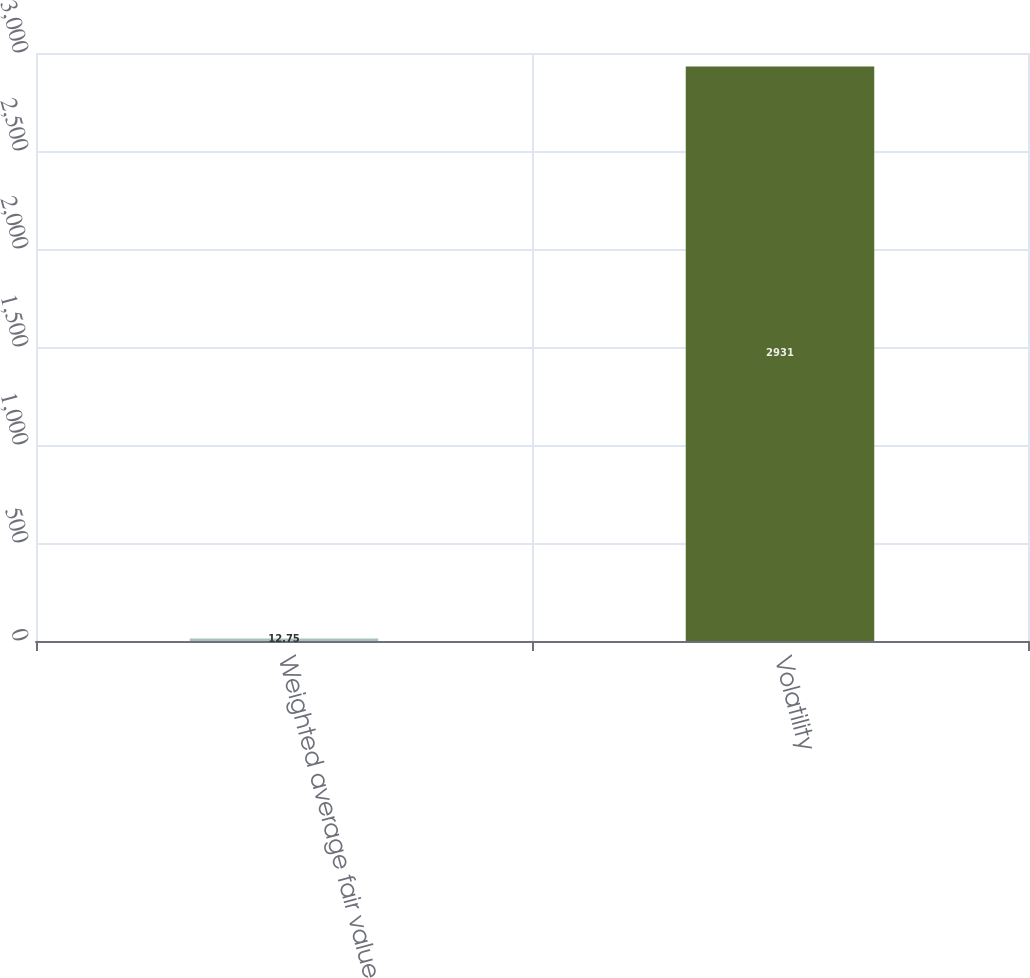Convert chart to OTSL. <chart><loc_0><loc_0><loc_500><loc_500><bar_chart><fcel>Weighted average fair value<fcel>Volatility<nl><fcel>12.75<fcel>2931<nl></chart> 